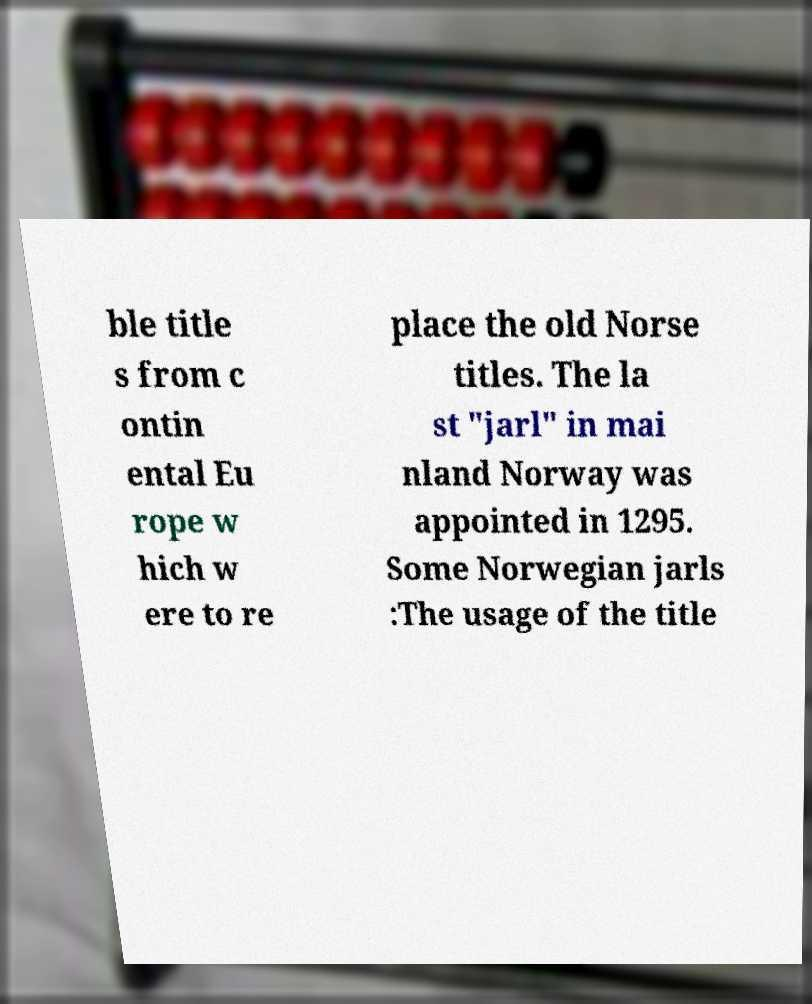Can you accurately transcribe the text from the provided image for me? ble title s from c ontin ental Eu rope w hich w ere to re place the old Norse titles. The la st "jarl" in mai nland Norway was appointed in 1295. Some Norwegian jarls :The usage of the title 